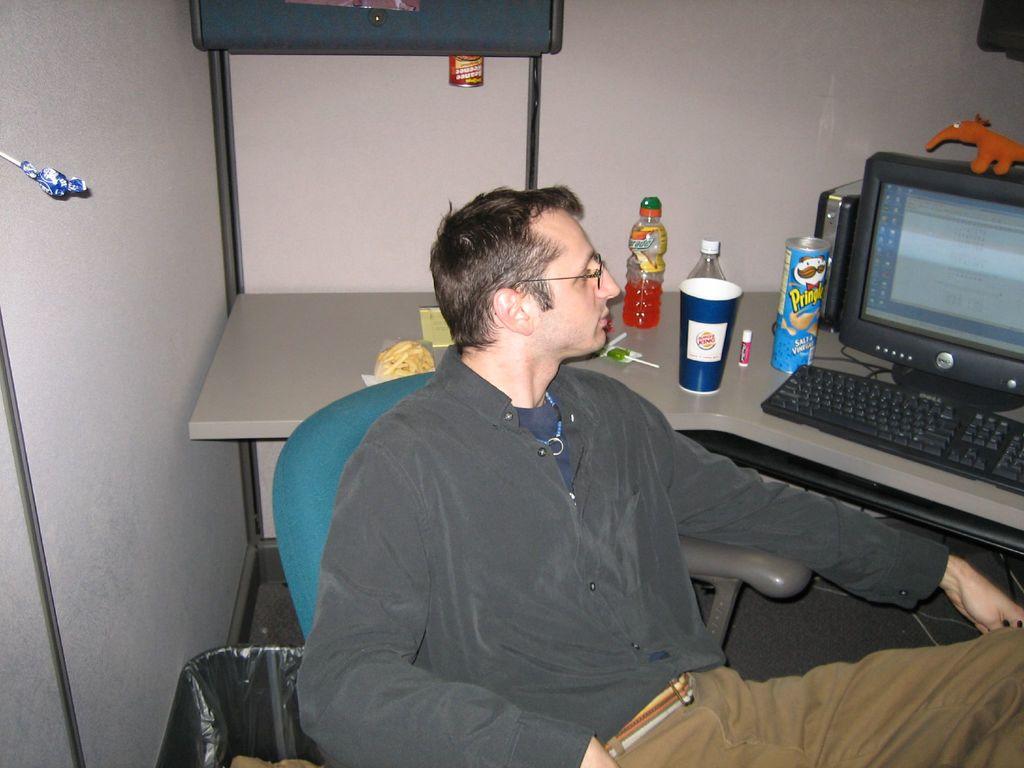What chips are those?
Make the answer very short. Pringles. 